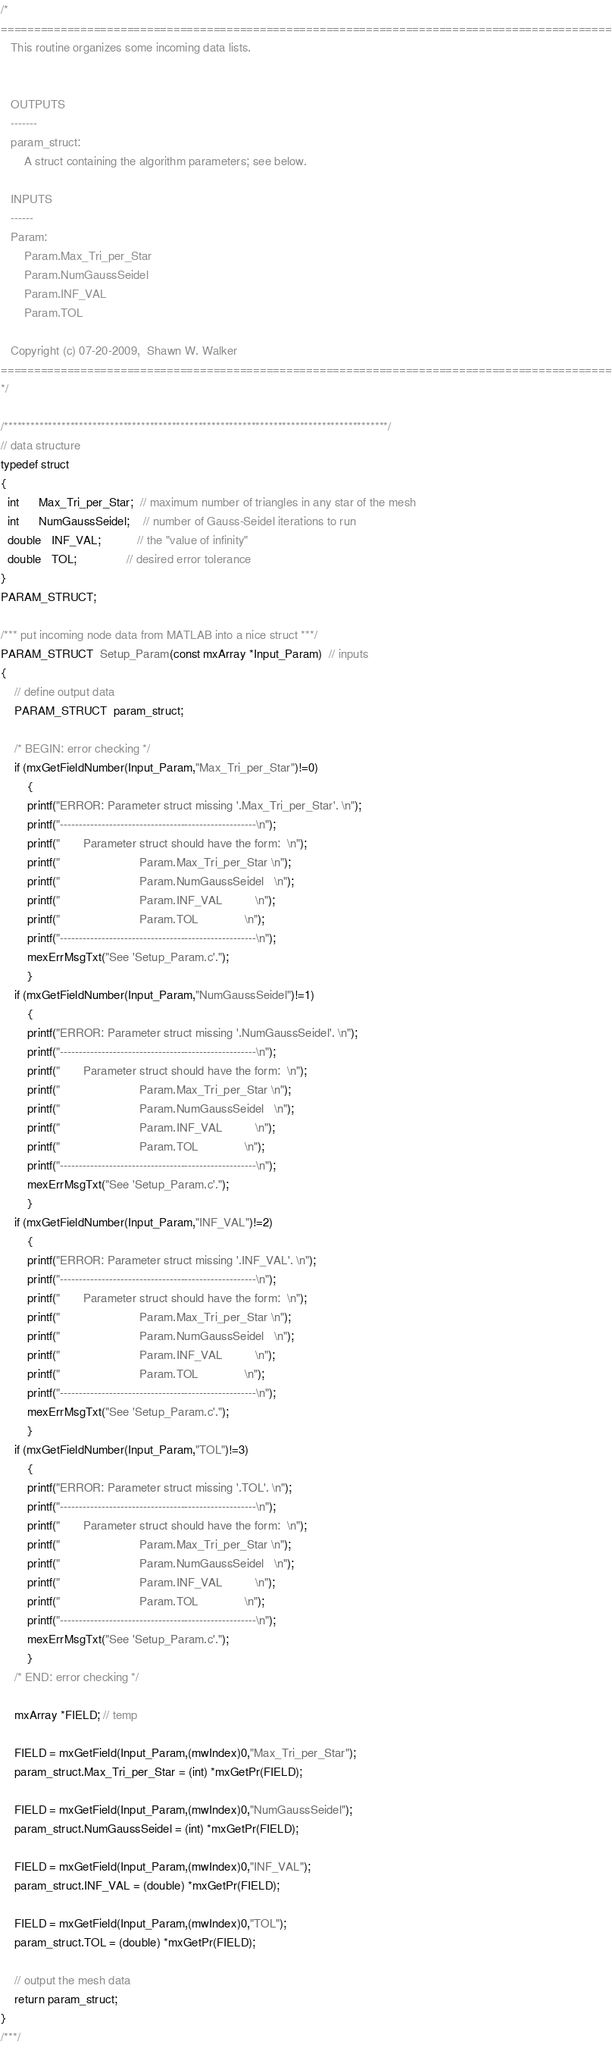<code> <loc_0><loc_0><loc_500><loc_500><_C_>/*
============================================================================================
   This routine organizes some incoming data lists.


   OUTPUTS
   -------
   param_struct:
       A struct containing the algorithm parameters; see below.

   INPUTS
   ------
   Param:
       Param.Max_Tri_per_Star
       Param.NumGaussSeidel
       Param.INF_VAL
       Param.TOL

   Copyright (c) 07-20-2009,  Shawn W. Walker
============================================================================================
*/

/***************************************************************************************/
// data structure
typedef struct
{
  int      Max_Tri_per_Star;  // maximum number of triangles in any star of the mesh
  int      NumGaussSeidel;    // number of Gauss-Seidel iterations to run
  double   INF_VAL;           // the "value of infinity"
  double   TOL;               // desired error tolerance
}
PARAM_STRUCT;

/*** put incoming node data from MATLAB into a nice struct ***/
PARAM_STRUCT  Setup_Param(const mxArray *Input_Param)  // inputs
{
	// define output data
	PARAM_STRUCT  param_struct;
	
	/* BEGIN: error checking */
	if (mxGetFieldNumber(Input_Param,"Max_Tri_per_Star")!=0)
		{
		printf("ERROR: Parameter struct missing '.Max_Tri_per_Star'. \n");
		printf("----------------------------------------------------\n");
		printf("       Parameter struct should have the form:  \n");
		printf("                        Param.Max_Tri_per_Star \n");
		printf("                        Param.NumGaussSeidel   \n");
		printf("                        Param.INF_VAL          \n");
		printf("                        Param.TOL              \n");
		printf("----------------------------------------------------\n");
		mexErrMsgTxt("See 'Setup_Param.c'.");
		}
	if (mxGetFieldNumber(Input_Param,"NumGaussSeidel")!=1)
		{
		printf("ERROR: Parameter struct missing '.NumGaussSeidel'. \n");
		printf("----------------------------------------------------\n");
		printf("       Parameter struct should have the form:  \n");
		printf("                        Param.Max_Tri_per_Star \n");
		printf("                        Param.NumGaussSeidel   \n");
		printf("                        Param.INF_VAL          \n");
		printf("                        Param.TOL              \n");
		printf("----------------------------------------------------\n");
		mexErrMsgTxt("See 'Setup_Param.c'.");
		}
	if (mxGetFieldNumber(Input_Param,"INF_VAL")!=2)
		{
		printf("ERROR: Parameter struct missing '.INF_VAL'. \n");
		printf("----------------------------------------------------\n");
		printf("       Parameter struct should have the form:  \n");
		printf("                        Param.Max_Tri_per_Star \n");
		printf("                        Param.NumGaussSeidel   \n");
		printf("                        Param.INF_VAL          \n");
		printf("                        Param.TOL              \n");
		printf("----------------------------------------------------\n");
		mexErrMsgTxt("See 'Setup_Param.c'.");
		}
	if (mxGetFieldNumber(Input_Param,"TOL")!=3)
		{
		printf("ERROR: Parameter struct missing '.TOL'. \n");
		printf("----------------------------------------------------\n");
		printf("       Parameter struct should have the form:  \n");
		printf("                        Param.Max_Tri_per_Star \n");
		printf("                        Param.NumGaussSeidel   \n");
		printf("                        Param.INF_VAL          \n");
		printf("                        Param.TOL              \n");
		printf("----------------------------------------------------\n");
		mexErrMsgTxt("See 'Setup_Param.c'.");
		}
	/* END: error checking */
	
	mxArray *FIELD; // temp
	
	FIELD = mxGetField(Input_Param,(mwIndex)0,"Max_Tri_per_Star");
	param_struct.Max_Tri_per_Star = (int) *mxGetPr(FIELD);
	
	FIELD = mxGetField(Input_Param,(mwIndex)0,"NumGaussSeidel");
	param_struct.NumGaussSeidel = (int) *mxGetPr(FIELD);

	FIELD = mxGetField(Input_Param,(mwIndex)0,"INF_VAL");
	param_struct.INF_VAL = (double) *mxGetPr(FIELD);
	
	FIELD = mxGetField(Input_Param,(mwIndex)0,"TOL");
	param_struct.TOL = (double) *mxGetPr(FIELD);
	
	// output the mesh data
	return param_struct;
}
/***/
</code> 